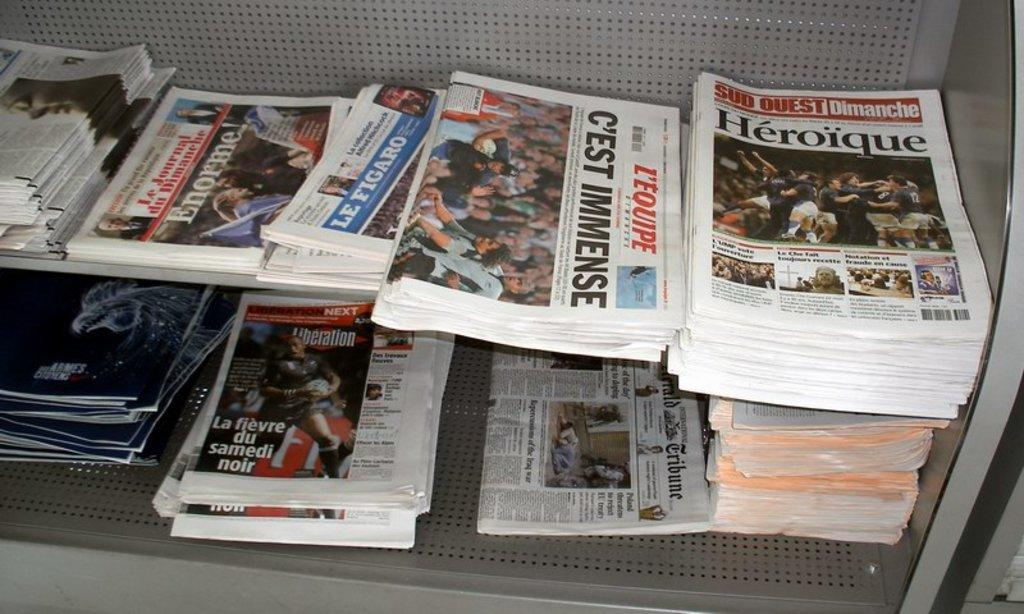<image>
Write a terse but informative summary of the picture. Heroique head news and C'est Immense headline on a newspaper. 